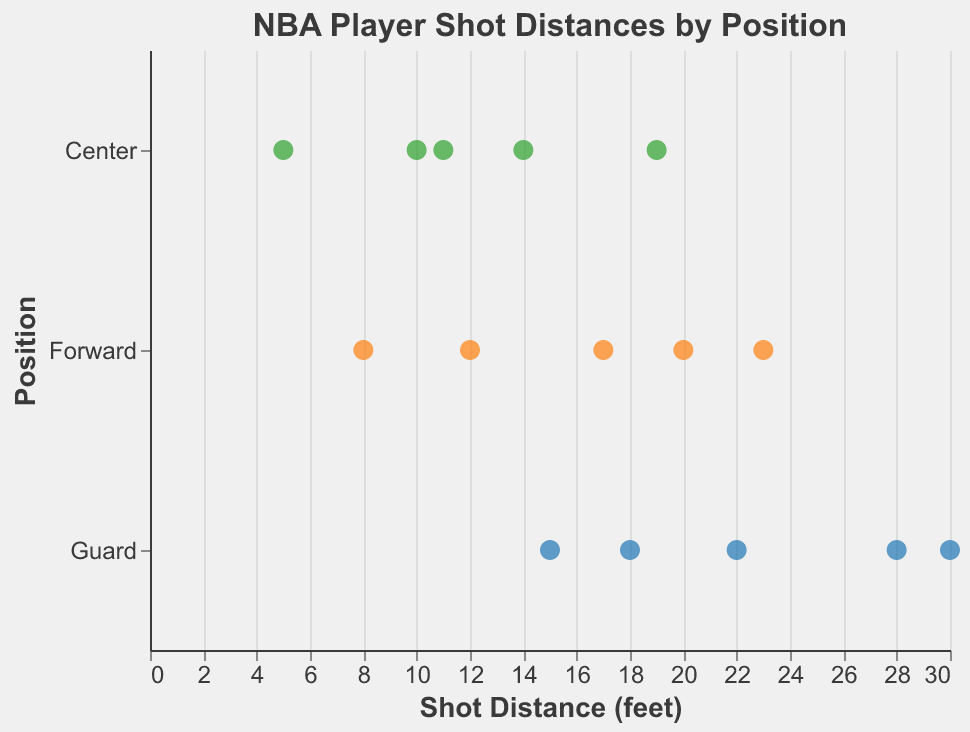What is the title of the strip plot? The title is displayed at the top of the plot. It is written as "NBA Player Shot Distances by Position"
Answer: NBA Player Shot Distances by Position Which position has the player with the greatest shot distance? The position of the player with the greatest value on the x-axis (Shot Distance) is searched in the data. Damian Lillard has a shot distance of 30, which is the greatest, and he is in the Guard position
Answer: Guard How many different Forward players are shown? By counting the number of data points corresponding to the 'Forward' category on the y-axis, we see there are five different players: LeBron James, Kevin Durant, Kawhi Leonard, Giannis Antetokounmpo, and Paul George
Answer: 5 What is the average shot distance for players in the Center position? Summing the shot distances of Centers (10 + 14 + 19 + 11 + 5) gives 59. Dividing the sum by the number of Centers (5) yields 59 / 5 = 11.8
Answer: 11.8 Which player has the shortest shot distance and what is it? The player with the smallest value on the x-axis (Shot Distance) is identified. Rudy Gobert has the shortest shot distance of 5
Answer: Rudy Gobert, 5 Compare the shot distance between Stephen Curry and LeBron James. Who has the longer shot distance? Examining their respective shot distances, Stephen Curry's 28 is compared with LeBron James' 12. Stephen Curry's shot distance is longer
Answer: Stephen Curry What is the range of shot distances for Guards? The maximum shot distance for Guards is 30 (Damian Lillard), and the minimum is 15 (Chris Paul). The range is calculated as 30 - 15 = 15
Answer: 15 Who is the Forward player with the highest shot distance and what is it? Among the Forward players, the highest shot distance of 23 belongs to Paul George
Answer: Paul George, 23 Which position has the most varied shot distances? By analyzing the spread of shot distance values within each position visually, the Guard position shows the highest dispersion in distances from 15 to 30, indicating the most variation
Answer: Guard 